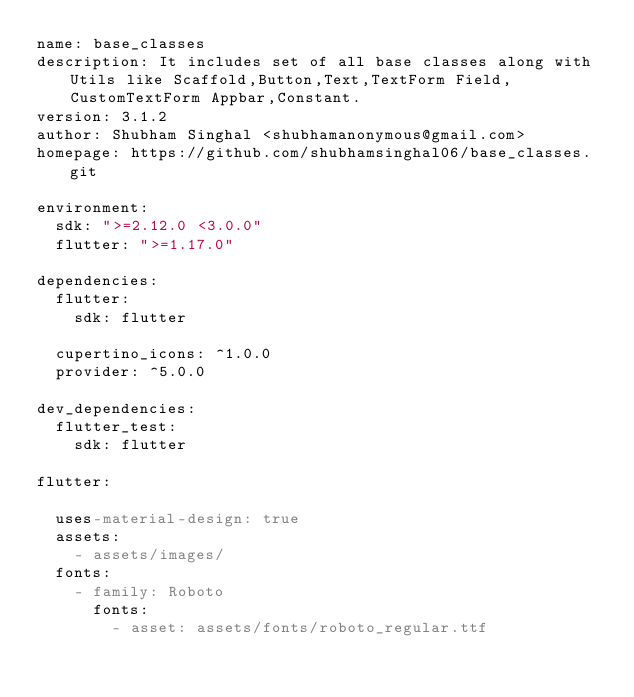Convert code to text. <code><loc_0><loc_0><loc_500><loc_500><_YAML_>name: base_classes
description: It includes set of all base classes along with Utils like Scaffold,Button,Text,TextForm Field, CustomTextForm Appbar,Constant.
version: 3.1.2
author: Shubham Singhal <shubhamanonymous@gmail.com>
homepage: https://github.com/shubhamsinghal06/base_classes.git

environment:
  sdk: ">=2.12.0 <3.0.0"
  flutter: ">=1.17.0"

dependencies:
  flutter:
    sdk: flutter

  cupertino_icons: ^1.0.0
  provider: ^5.0.0

dev_dependencies:
  flutter_test:
    sdk: flutter

flutter:

  uses-material-design: true
  assets:
    - assets/images/
  fonts:
    - family: Roboto
      fonts:
        - asset: assets/fonts/roboto_regular.ttf
</code> 